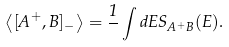Convert formula to latex. <formula><loc_0><loc_0><loc_500><loc_500>\left \langle [ A ^ { + } , B ] _ { - } \right \rangle = \frac { 1 } { } \int d E S _ { A ^ { + } B } ( E ) .</formula> 